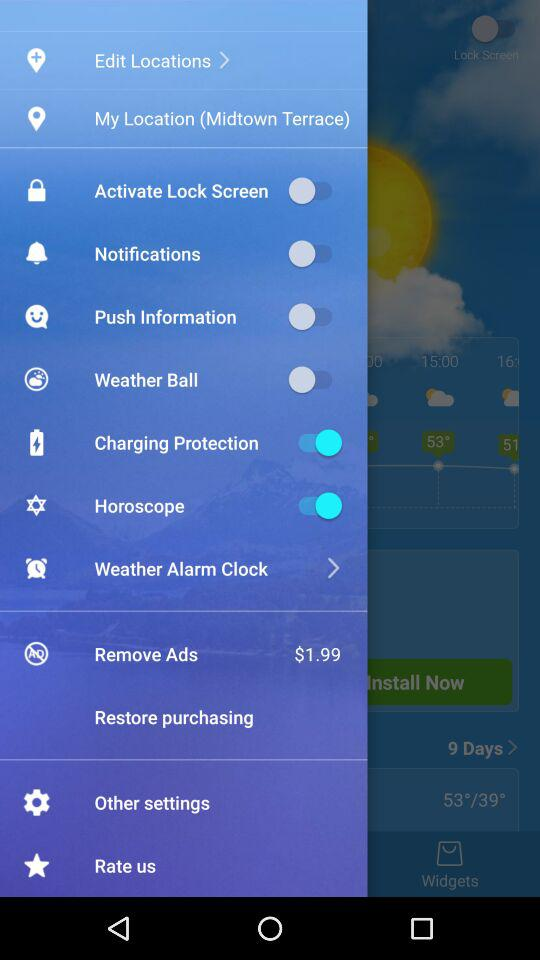What is the shown location? The shown location is Midtown Terrace. 